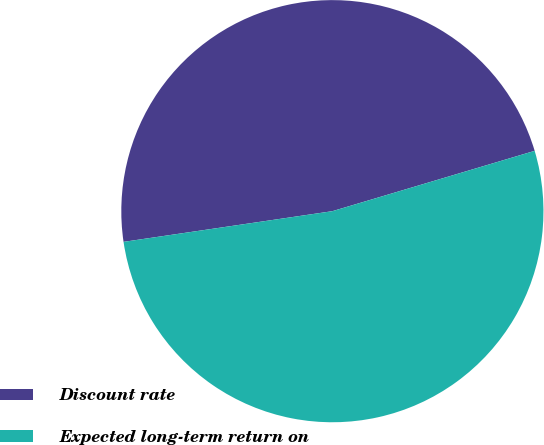<chart> <loc_0><loc_0><loc_500><loc_500><pie_chart><fcel>Discount rate<fcel>Expected long-term return on<nl><fcel>47.71%<fcel>52.29%<nl></chart> 